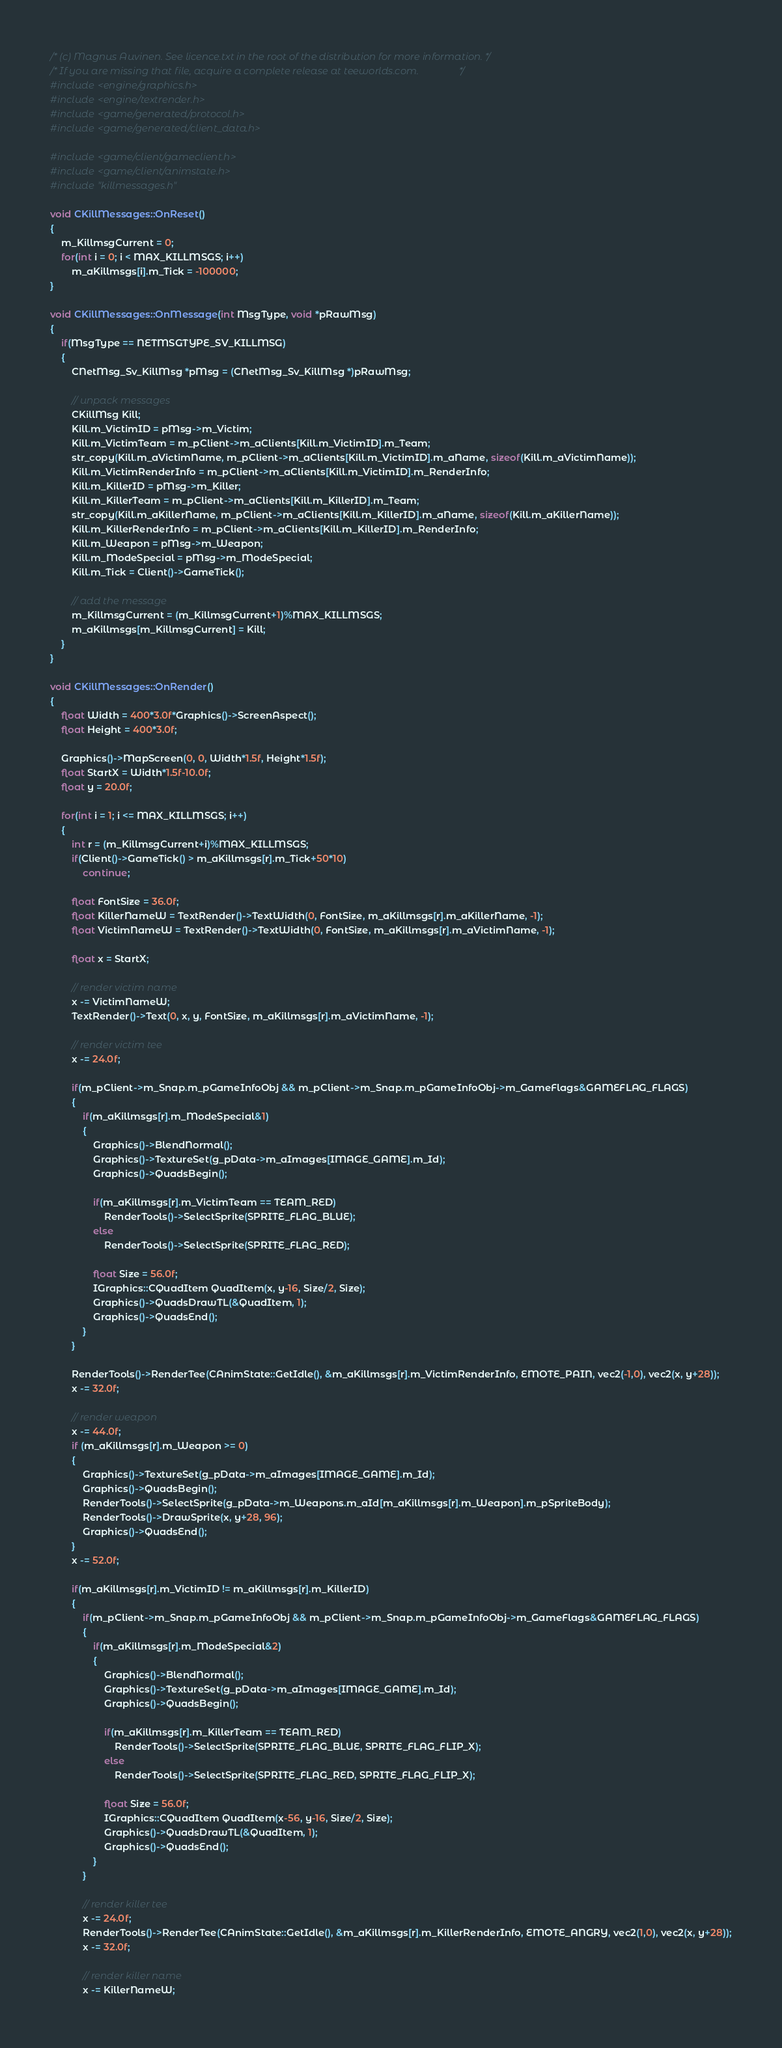<code> <loc_0><loc_0><loc_500><loc_500><_C++_>/* (c) Magnus Auvinen. See licence.txt in the root of the distribution for more information. */
/* If you are missing that file, acquire a complete release at teeworlds.com.                */
#include <engine/graphics.h>
#include <engine/textrender.h>
#include <game/generated/protocol.h>
#include <game/generated/client_data.h>

#include <game/client/gameclient.h>
#include <game/client/animstate.h>
#include "killmessages.h"

void CKillMessages::OnReset()
{
	m_KillmsgCurrent = 0;
	for(int i = 0; i < MAX_KILLMSGS; i++)
		m_aKillmsgs[i].m_Tick = -100000;
}

void CKillMessages::OnMessage(int MsgType, void *pRawMsg)
{
	if(MsgType == NETMSGTYPE_SV_KILLMSG)
	{
		CNetMsg_Sv_KillMsg *pMsg = (CNetMsg_Sv_KillMsg *)pRawMsg;

		// unpack messages
		CKillMsg Kill;
		Kill.m_VictimID = pMsg->m_Victim;
		Kill.m_VictimTeam = m_pClient->m_aClients[Kill.m_VictimID].m_Team;
		str_copy(Kill.m_aVictimName, m_pClient->m_aClients[Kill.m_VictimID].m_aName, sizeof(Kill.m_aVictimName));
		Kill.m_VictimRenderInfo = m_pClient->m_aClients[Kill.m_VictimID].m_RenderInfo;
		Kill.m_KillerID = pMsg->m_Killer;
		Kill.m_KillerTeam = m_pClient->m_aClients[Kill.m_KillerID].m_Team;
		str_copy(Kill.m_aKillerName, m_pClient->m_aClients[Kill.m_KillerID].m_aName, sizeof(Kill.m_aKillerName));
		Kill.m_KillerRenderInfo = m_pClient->m_aClients[Kill.m_KillerID].m_RenderInfo;
		Kill.m_Weapon = pMsg->m_Weapon;
		Kill.m_ModeSpecial = pMsg->m_ModeSpecial;
		Kill.m_Tick = Client()->GameTick();

		// add the message
		m_KillmsgCurrent = (m_KillmsgCurrent+1)%MAX_KILLMSGS;
		m_aKillmsgs[m_KillmsgCurrent] = Kill;
	}
}

void CKillMessages::OnRender()
{
	float Width = 400*3.0f*Graphics()->ScreenAspect();
	float Height = 400*3.0f;

	Graphics()->MapScreen(0, 0, Width*1.5f, Height*1.5f);
	float StartX = Width*1.5f-10.0f;
	float y = 20.0f;

	for(int i = 1; i <= MAX_KILLMSGS; i++)
	{
		int r = (m_KillmsgCurrent+i)%MAX_KILLMSGS;
		if(Client()->GameTick() > m_aKillmsgs[r].m_Tick+50*10)
			continue;

		float FontSize = 36.0f;
		float KillerNameW = TextRender()->TextWidth(0, FontSize, m_aKillmsgs[r].m_aKillerName, -1);
		float VictimNameW = TextRender()->TextWidth(0, FontSize, m_aKillmsgs[r].m_aVictimName, -1);

		float x = StartX;

		// render victim name
		x -= VictimNameW;
		TextRender()->Text(0, x, y, FontSize, m_aKillmsgs[r].m_aVictimName, -1);

		// render victim tee
		x -= 24.0f;

		if(m_pClient->m_Snap.m_pGameInfoObj && m_pClient->m_Snap.m_pGameInfoObj->m_GameFlags&GAMEFLAG_FLAGS)
		{
			if(m_aKillmsgs[r].m_ModeSpecial&1)
			{
				Graphics()->BlendNormal();
				Graphics()->TextureSet(g_pData->m_aImages[IMAGE_GAME].m_Id);
				Graphics()->QuadsBegin();

				if(m_aKillmsgs[r].m_VictimTeam == TEAM_RED)
					RenderTools()->SelectSprite(SPRITE_FLAG_BLUE);
				else
					RenderTools()->SelectSprite(SPRITE_FLAG_RED);

				float Size = 56.0f;
				IGraphics::CQuadItem QuadItem(x, y-16, Size/2, Size);
				Graphics()->QuadsDrawTL(&QuadItem, 1);
				Graphics()->QuadsEnd();
			}
		}

		RenderTools()->RenderTee(CAnimState::GetIdle(), &m_aKillmsgs[r].m_VictimRenderInfo, EMOTE_PAIN, vec2(-1,0), vec2(x, y+28));
		x -= 32.0f;

		// render weapon
		x -= 44.0f;
		if (m_aKillmsgs[r].m_Weapon >= 0)
		{
			Graphics()->TextureSet(g_pData->m_aImages[IMAGE_GAME].m_Id);
			Graphics()->QuadsBegin();
			RenderTools()->SelectSprite(g_pData->m_Weapons.m_aId[m_aKillmsgs[r].m_Weapon].m_pSpriteBody);
			RenderTools()->DrawSprite(x, y+28, 96);
			Graphics()->QuadsEnd();
		}
		x -= 52.0f;

		if(m_aKillmsgs[r].m_VictimID != m_aKillmsgs[r].m_KillerID)
		{
			if(m_pClient->m_Snap.m_pGameInfoObj && m_pClient->m_Snap.m_pGameInfoObj->m_GameFlags&GAMEFLAG_FLAGS)
			{
				if(m_aKillmsgs[r].m_ModeSpecial&2)
				{
					Graphics()->BlendNormal();
					Graphics()->TextureSet(g_pData->m_aImages[IMAGE_GAME].m_Id);
					Graphics()->QuadsBegin();

					if(m_aKillmsgs[r].m_KillerTeam == TEAM_RED)
						RenderTools()->SelectSprite(SPRITE_FLAG_BLUE, SPRITE_FLAG_FLIP_X);
					else
						RenderTools()->SelectSprite(SPRITE_FLAG_RED, SPRITE_FLAG_FLIP_X);

					float Size = 56.0f;
					IGraphics::CQuadItem QuadItem(x-56, y-16, Size/2, Size);
					Graphics()->QuadsDrawTL(&QuadItem, 1);
					Graphics()->QuadsEnd();
				}
			}

			// render killer tee
			x -= 24.0f;
			RenderTools()->RenderTee(CAnimState::GetIdle(), &m_aKillmsgs[r].m_KillerRenderInfo, EMOTE_ANGRY, vec2(1,0), vec2(x, y+28));
			x -= 32.0f;

			// render killer name
			x -= KillerNameW;</code> 